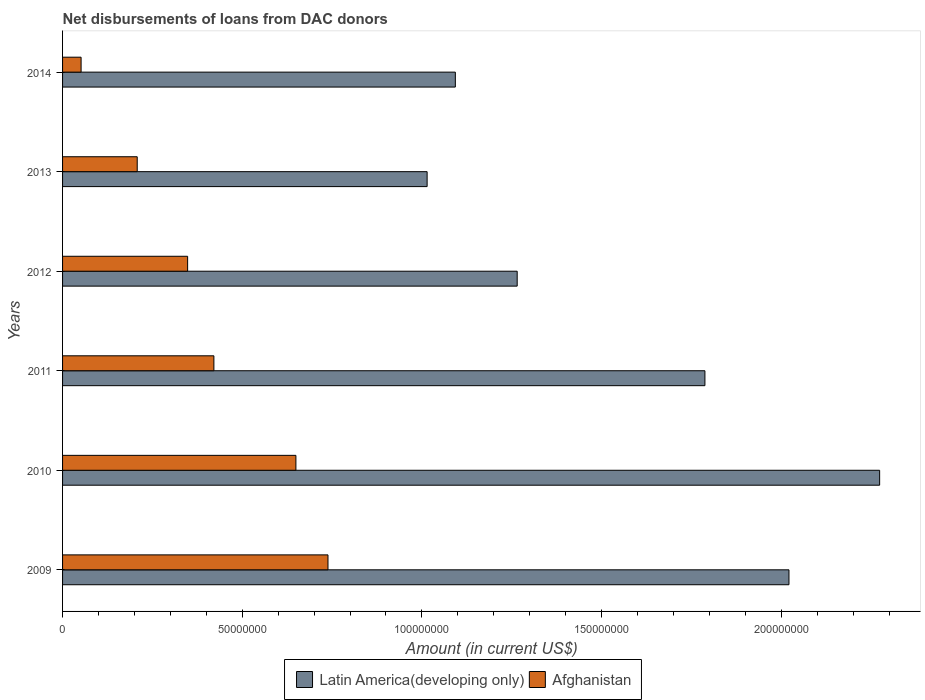How many different coloured bars are there?
Give a very brief answer. 2. How many groups of bars are there?
Keep it short and to the point. 6. Are the number of bars on each tick of the Y-axis equal?
Give a very brief answer. Yes. How many bars are there on the 5th tick from the top?
Make the answer very short. 2. How many bars are there on the 1st tick from the bottom?
Ensure brevity in your answer.  2. What is the label of the 1st group of bars from the top?
Offer a very short reply. 2014. What is the amount of loans disbursed in Afghanistan in 2011?
Ensure brevity in your answer.  4.21e+07. Across all years, what is the maximum amount of loans disbursed in Afghanistan?
Make the answer very short. 7.39e+07. Across all years, what is the minimum amount of loans disbursed in Latin America(developing only)?
Keep it short and to the point. 1.01e+08. In which year was the amount of loans disbursed in Afghanistan maximum?
Provide a short and direct response. 2009. What is the total amount of loans disbursed in Latin America(developing only) in the graph?
Offer a terse response. 9.46e+08. What is the difference between the amount of loans disbursed in Afghanistan in 2009 and that in 2010?
Offer a terse response. 8.93e+06. What is the difference between the amount of loans disbursed in Afghanistan in 2011 and the amount of loans disbursed in Latin America(developing only) in 2013?
Make the answer very short. -5.93e+07. What is the average amount of loans disbursed in Latin America(developing only) per year?
Ensure brevity in your answer.  1.58e+08. In the year 2009, what is the difference between the amount of loans disbursed in Latin America(developing only) and amount of loans disbursed in Afghanistan?
Keep it short and to the point. 1.28e+08. In how many years, is the amount of loans disbursed in Afghanistan greater than 200000000 US$?
Your answer should be very brief. 0. What is the ratio of the amount of loans disbursed in Afghanistan in 2010 to that in 2011?
Provide a succinct answer. 1.54. Is the amount of loans disbursed in Latin America(developing only) in 2009 less than that in 2014?
Keep it short and to the point. No. Is the difference between the amount of loans disbursed in Latin America(developing only) in 2009 and 2014 greater than the difference between the amount of loans disbursed in Afghanistan in 2009 and 2014?
Ensure brevity in your answer.  Yes. What is the difference between the highest and the second highest amount of loans disbursed in Latin America(developing only)?
Give a very brief answer. 2.52e+07. What is the difference between the highest and the lowest amount of loans disbursed in Afghanistan?
Ensure brevity in your answer.  6.87e+07. In how many years, is the amount of loans disbursed in Latin America(developing only) greater than the average amount of loans disbursed in Latin America(developing only) taken over all years?
Your response must be concise. 3. What does the 1st bar from the top in 2009 represents?
Your response must be concise. Afghanistan. What does the 2nd bar from the bottom in 2012 represents?
Ensure brevity in your answer.  Afghanistan. How many bars are there?
Give a very brief answer. 12. Are all the bars in the graph horizontal?
Your answer should be very brief. Yes. What is the difference between two consecutive major ticks on the X-axis?
Keep it short and to the point. 5.00e+07. Does the graph contain any zero values?
Make the answer very short. No. Where does the legend appear in the graph?
Provide a succinct answer. Bottom center. What is the title of the graph?
Your answer should be compact. Net disbursements of loans from DAC donors. What is the label or title of the Y-axis?
Provide a short and direct response. Years. What is the Amount (in current US$) in Latin America(developing only) in 2009?
Ensure brevity in your answer.  2.02e+08. What is the Amount (in current US$) of Afghanistan in 2009?
Offer a very short reply. 7.39e+07. What is the Amount (in current US$) in Latin America(developing only) in 2010?
Provide a succinct answer. 2.27e+08. What is the Amount (in current US$) of Afghanistan in 2010?
Give a very brief answer. 6.49e+07. What is the Amount (in current US$) of Latin America(developing only) in 2011?
Your answer should be compact. 1.79e+08. What is the Amount (in current US$) of Afghanistan in 2011?
Ensure brevity in your answer.  4.21e+07. What is the Amount (in current US$) in Latin America(developing only) in 2012?
Give a very brief answer. 1.27e+08. What is the Amount (in current US$) of Afghanistan in 2012?
Your answer should be very brief. 3.48e+07. What is the Amount (in current US$) of Latin America(developing only) in 2013?
Your answer should be very brief. 1.01e+08. What is the Amount (in current US$) in Afghanistan in 2013?
Your answer should be very brief. 2.08e+07. What is the Amount (in current US$) in Latin America(developing only) in 2014?
Provide a succinct answer. 1.09e+08. What is the Amount (in current US$) of Afghanistan in 2014?
Your answer should be compact. 5.16e+06. Across all years, what is the maximum Amount (in current US$) of Latin America(developing only)?
Your answer should be very brief. 2.27e+08. Across all years, what is the maximum Amount (in current US$) of Afghanistan?
Your response must be concise. 7.39e+07. Across all years, what is the minimum Amount (in current US$) in Latin America(developing only)?
Ensure brevity in your answer.  1.01e+08. Across all years, what is the minimum Amount (in current US$) in Afghanistan?
Offer a terse response. 5.16e+06. What is the total Amount (in current US$) in Latin America(developing only) in the graph?
Ensure brevity in your answer.  9.46e+08. What is the total Amount (in current US$) in Afghanistan in the graph?
Provide a short and direct response. 2.42e+08. What is the difference between the Amount (in current US$) in Latin America(developing only) in 2009 and that in 2010?
Ensure brevity in your answer.  -2.52e+07. What is the difference between the Amount (in current US$) in Afghanistan in 2009 and that in 2010?
Keep it short and to the point. 8.93e+06. What is the difference between the Amount (in current US$) of Latin America(developing only) in 2009 and that in 2011?
Provide a short and direct response. 2.34e+07. What is the difference between the Amount (in current US$) in Afghanistan in 2009 and that in 2011?
Your answer should be compact. 3.17e+07. What is the difference between the Amount (in current US$) in Latin America(developing only) in 2009 and that in 2012?
Your answer should be very brief. 7.56e+07. What is the difference between the Amount (in current US$) in Afghanistan in 2009 and that in 2012?
Your response must be concise. 3.91e+07. What is the difference between the Amount (in current US$) in Latin America(developing only) in 2009 and that in 2013?
Ensure brevity in your answer.  1.01e+08. What is the difference between the Amount (in current US$) of Afghanistan in 2009 and that in 2013?
Offer a very short reply. 5.31e+07. What is the difference between the Amount (in current US$) of Latin America(developing only) in 2009 and that in 2014?
Give a very brief answer. 9.28e+07. What is the difference between the Amount (in current US$) of Afghanistan in 2009 and that in 2014?
Keep it short and to the point. 6.87e+07. What is the difference between the Amount (in current US$) in Latin America(developing only) in 2010 and that in 2011?
Give a very brief answer. 4.86e+07. What is the difference between the Amount (in current US$) of Afghanistan in 2010 and that in 2011?
Offer a terse response. 2.28e+07. What is the difference between the Amount (in current US$) of Latin America(developing only) in 2010 and that in 2012?
Your response must be concise. 1.01e+08. What is the difference between the Amount (in current US$) of Afghanistan in 2010 and that in 2012?
Provide a succinct answer. 3.01e+07. What is the difference between the Amount (in current US$) in Latin America(developing only) in 2010 and that in 2013?
Offer a very short reply. 1.26e+08. What is the difference between the Amount (in current US$) of Afghanistan in 2010 and that in 2013?
Ensure brevity in your answer.  4.42e+07. What is the difference between the Amount (in current US$) in Latin America(developing only) in 2010 and that in 2014?
Ensure brevity in your answer.  1.18e+08. What is the difference between the Amount (in current US$) in Afghanistan in 2010 and that in 2014?
Offer a very short reply. 5.98e+07. What is the difference between the Amount (in current US$) in Latin America(developing only) in 2011 and that in 2012?
Offer a terse response. 5.22e+07. What is the difference between the Amount (in current US$) of Afghanistan in 2011 and that in 2012?
Your answer should be compact. 7.31e+06. What is the difference between the Amount (in current US$) of Latin America(developing only) in 2011 and that in 2013?
Give a very brief answer. 7.73e+07. What is the difference between the Amount (in current US$) in Afghanistan in 2011 and that in 2013?
Provide a succinct answer. 2.13e+07. What is the difference between the Amount (in current US$) in Latin America(developing only) in 2011 and that in 2014?
Provide a short and direct response. 6.95e+07. What is the difference between the Amount (in current US$) of Afghanistan in 2011 and that in 2014?
Offer a very short reply. 3.70e+07. What is the difference between the Amount (in current US$) in Latin America(developing only) in 2012 and that in 2013?
Make the answer very short. 2.51e+07. What is the difference between the Amount (in current US$) in Afghanistan in 2012 and that in 2013?
Provide a short and direct response. 1.40e+07. What is the difference between the Amount (in current US$) in Latin America(developing only) in 2012 and that in 2014?
Ensure brevity in your answer.  1.72e+07. What is the difference between the Amount (in current US$) in Afghanistan in 2012 and that in 2014?
Offer a terse response. 2.96e+07. What is the difference between the Amount (in current US$) of Latin America(developing only) in 2013 and that in 2014?
Provide a succinct answer. -7.85e+06. What is the difference between the Amount (in current US$) in Afghanistan in 2013 and that in 2014?
Provide a succinct answer. 1.56e+07. What is the difference between the Amount (in current US$) of Latin America(developing only) in 2009 and the Amount (in current US$) of Afghanistan in 2010?
Give a very brief answer. 1.37e+08. What is the difference between the Amount (in current US$) in Latin America(developing only) in 2009 and the Amount (in current US$) in Afghanistan in 2011?
Your answer should be compact. 1.60e+08. What is the difference between the Amount (in current US$) in Latin America(developing only) in 2009 and the Amount (in current US$) in Afghanistan in 2012?
Offer a very short reply. 1.67e+08. What is the difference between the Amount (in current US$) of Latin America(developing only) in 2009 and the Amount (in current US$) of Afghanistan in 2013?
Your answer should be compact. 1.81e+08. What is the difference between the Amount (in current US$) in Latin America(developing only) in 2009 and the Amount (in current US$) in Afghanistan in 2014?
Your answer should be compact. 1.97e+08. What is the difference between the Amount (in current US$) of Latin America(developing only) in 2010 and the Amount (in current US$) of Afghanistan in 2011?
Your answer should be compact. 1.85e+08. What is the difference between the Amount (in current US$) of Latin America(developing only) in 2010 and the Amount (in current US$) of Afghanistan in 2012?
Make the answer very short. 1.93e+08. What is the difference between the Amount (in current US$) of Latin America(developing only) in 2010 and the Amount (in current US$) of Afghanistan in 2013?
Your response must be concise. 2.07e+08. What is the difference between the Amount (in current US$) in Latin America(developing only) in 2010 and the Amount (in current US$) in Afghanistan in 2014?
Your response must be concise. 2.22e+08. What is the difference between the Amount (in current US$) in Latin America(developing only) in 2011 and the Amount (in current US$) in Afghanistan in 2012?
Keep it short and to the point. 1.44e+08. What is the difference between the Amount (in current US$) in Latin America(developing only) in 2011 and the Amount (in current US$) in Afghanistan in 2013?
Keep it short and to the point. 1.58e+08. What is the difference between the Amount (in current US$) of Latin America(developing only) in 2011 and the Amount (in current US$) of Afghanistan in 2014?
Give a very brief answer. 1.74e+08. What is the difference between the Amount (in current US$) of Latin America(developing only) in 2012 and the Amount (in current US$) of Afghanistan in 2013?
Offer a very short reply. 1.06e+08. What is the difference between the Amount (in current US$) of Latin America(developing only) in 2012 and the Amount (in current US$) of Afghanistan in 2014?
Make the answer very short. 1.21e+08. What is the difference between the Amount (in current US$) of Latin America(developing only) in 2013 and the Amount (in current US$) of Afghanistan in 2014?
Provide a short and direct response. 9.63e+07. What is the average Amount (in current US$) in Latin America(developing only) per year?
Provide a short and direct response. 1.58e+08. What is the average Amount (in current US$) in Afghanistan per year?
Your answer should be compact. 4.03e+07. In the year 2009, what is the difference between the Amount (in current US$) in Latin America(developing only) and Amount (in current US$) in Afghanistan?
Make the answer very short. 1.28e+08. In the year 2010, what is the difference between the Amount (in current US$) in Latin America(developing only) and Amount (in current US$) in Afghanistan?
Offer a very short reply. 1.62e+08. In the year 2011, what is the difference between the Amount (in current US$) of Latin America(developing only) and Amount (in current US$) of Afghanistan?
Ensure brevity in your answer.  1.37e+08. In the year 2012, what is the difference between the Amount (in current US$) in Latin America(developing only) and Amount (in current US$) in Afghanistan?
Your answer should be very brief. 9.17e+07. In the year 2013, what is the difference between the Amount (in current US$) in Latin America(developing only) and Amount (in current US$) in Afghanistan?
Give a very brief answer. 8.07e+07. In the year 2014, what is the difference between the Amount (in current US$) in Latin America(developing only) and Amount (in current US$) in Afghanistan?
Give a very brief answer. 1.04e+08. What is the ratio of the Amount (in current US$) in Latin America(developing only) in 2009 to that in 2010?
Your answer should be very brief. 0.89. What is the ratio of the Amount (in current US$) in Afghanistan in 2009 to that in 2010?
Your answer should be compact. 1.14. What is the ratio of the Amount (in current US$) of Latin America(developing only) in 2009 to that in 2011?
Offer a terse response. 1.13. What is the ratio of the Amount (in current US$) of Afghanistan in 2009 to that in 2011?
Give a very brief answer. 1.75. What is the ratio of the Amount (in current US$) of Latin America(developing only) in 2009 to that in 2012?
Provide a succinct answer. 1.6. What is the ratio of the Amount (in current US$) of Afghanistan in 2009 to that in 2012?
Offer a very short reply. 2.12. What is the ratio of the Amount (in current US$) in Latin America(developing only) in 2009 to that in 2013?
Make the answer very short. 1.99. What is the ratio of the Amount (in current US$) in Afghanistan in 2009 to that in 2013?
Provide a succinct answer. 3.56. What is the ratio of the Amount (in current US$) in Latin America(developing only) in 2009 to that in 2014?
Ensure brevity in your answer.  1.85. What is the ratio of the Amount (in current US$) in Afghanistan in 2009 to that in 2014?
Provide a short and direct response. 14.33. What is the ratio of the Amount (in current US$) in Latin America(developing only) in 2010 to that in 2011?
Make the answer very short. 1.27. What is the ratio of the Amount (in current US$) in Afghanistan in 2010 to that in 2011?
Ensure brevity in your answer.  1.54. What is the ratio of the Amount (in current US$) in Latin America(developing only) in 2010 to that in 2012?
Give a very brief answer. 1.8. What is the ratio of the Amount (in current US$) of Afghanistan in 2010 to that in 2012?
Offer a terse response. 1.87. What is the ratio of the Amount (in current US$) in Latin America(developing only) in 2010 to that in 2013?
Offer a terse response. 2.24. What is the ratio of the Amount (in current US$) of Afghanistan in 2010 to that in 2013?
Offer a terse response. 3.13. What is the ratio of the Amount (in current US$) in Latin America(developing only) in 2010 to that in 2014?
Ensure brevity in your answer.  2.08. What is the ratio of the Amount (in current US$) in Afghanistan in 2010 to that in 2014?
Provide a short and direct response. 12.6. What is the ratio of the Amount (in current US$) in Latin America(developing only) in 2011 to that in 2012?
Offer a very short reply. 1.41. What is the ratio of the Amount (in current US$) of Afghanistan in 2011 to that in 2012?
Your answer should be compact. 1.21. What is the ratio of the Amount (in current US$) in Latin America(developing only) in 2011 to that in 2013?
Give a very brief answer. 1.76. What is the ratio of the Amount (in current US$) in Afghanistan in 2011 to that in 2013?
Provide a short and direct response. 2.03. What is the ratio of the Amount (in current US$) in Latin America(developing only) in 2011 to that in 2014?
Provide a short and direct response. 1.64. What is the ratio of the Amount (in current US$) of Afghanistan in 2011 to that in 2014?
Ensure brevity in your answer.  8.17. What is the ratio of the Amount (in current US$) in Latin America(developing only) in 2012 to that in 2013?
Ensure brevity in your answer.  1.25. What is the ratio of the Amount (in current US$) of Afghanistan in 2012 to that in 2013?
Give a very brief answer. 1.68. What is the ratio of the Amount (in current US$) of Latin America(developing only) in 2012 to that in 2014?
Keep it short and to the point. 1.16. What is the ratio of the Amount (in current US$) of Afghanistan in 2012 to that in 2014?
Provide a succinct answer. 6.75. What is the ratio of the Amount (in current US$) of Latin America(developing only) in 2013 to that in 2014?
Your answer should be very brief. 0.93. What is the ratio of the Amount (in current US$) of Afghanistan in 2013 to that in 2014?
Your answer should be compact. 4.03. What is the difference between the highest and the second highest Amount (in current US$) in Latin America(developing only)?
Provide a short and direct response. 2.52e+07. What is the difference between the highest and the second highest Amount (in current US$) in Afghanistan?
Provide a short and direct response. 8.93e+06. What is the difference between the highest and the lowest Amount (in current US$) in Latin America(developing only)?
Your answer should be very brief. 1.26e+08. What is the difference between the highest and the lowest Amount (in current US$) of Afghanistan?
Keep it short and to the point. 6.87e+07. 